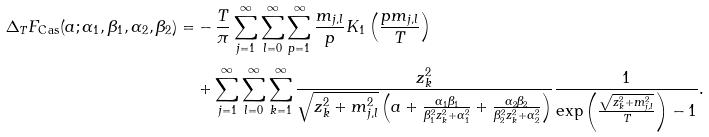<formula> <loc_0><loc_0><loc_500><loc_500>\Delta _ { T } F _ { \text {Cas} } ( a ; \alpha _ { 1 } , \beta _ { 1 } , \alpha _ { 2 } , \beta _ { 2 } ) = & - \frac { T } { \pi } \sum _ { j = 1 } ^ { \infty } \sum _ { l = 0 } ^ { \infty } \sum _ { p = 1 } ^ { \infty } \frac { m _ { j , l } } { p } K _ { 1 } \left ( \frac { p m _ { j , l } } { T } \right ) \\ & + \sum _ { j = 1 } ^ { \infty } \sum _ { l = 0 } ^ { \infty } \sum _ { k = 1 } ^ { \infty } \frac { z _ { k } ^ { 2 } } { \sqrt { z _ { k } ^ { 2 } + m _ { j , l } ^ { 2 } } \left ( a + \frac { \alpha _ { 1 } \beta _ { 1 } } { \beta _ { 1 } ^ { 2 } z _ { k } ^ { 2 } + \alpha _ { 1 } ^ { 2 } } + \frac { \alpha _ { 2 } \beta _ { 2 } } { \beta _ { 2 } ^ { 2 } z _ { k } ^ { 2 } + \alpha _ { 2 } ^ { 2 } } \right ) } \frac { 1 } { \exp \left ( \frac { \sqrt { z _ { k } ^ { 2 } + m _ { j , l } ^ { 2 } } } { T } \right ) - 1 } .</formula> 